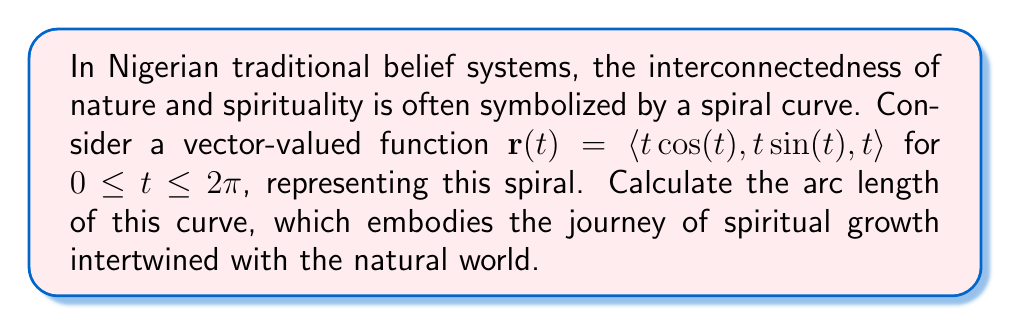Can you solve this math problem? To find the arc length of the curve, we'll follow these steps:

1) The arc length formula for a vector-valued function is:

   $$L = \int_a^b \|\mathbf{r}'(t)\| dt$$

2) First, we need to find $\mathbf{r}'(t)$:
   
   $$\mathbf{r}'(t) = \langle \cos(t) - t\sin(t), \sin(t) + t\cos(t), 1 \rangle$$

3) Now, we calculate $\|\mathbf{r}'(t)\|$:

   $$\begin{align}
   \|\mathbf{r}'(t)\| &= \sqrt{(\cos(t) - t\sin(t))^2 + (\sin(t) + t\cos(t))^2 + 1^2} \\
   &= \sqrt{\cos^2(t) - 2t\cos(t)\sin(t) + t^2\sin^2(t) + \sin^2(t) + 2t\sin(t)\cos(t) + t^2\cos^2(t) + 1} \\
   &= \sqrt{\cos^2(t) + \sin^2(t) + t^2(\sin^2(t) + \cos^2(t)) + 1} \\
   &= \sqrt{1 + t^2 + 1} \\
   &= \sqrt{t^2 + 2}
   \end{align}$$

4) Now we can set up our integral:

   $$L = \int_0^{2\pi} \sqrt{t^2 + 2} dt$$

5) This integral doesn't have an elementary antiderivative. We can solve it using the hyperbolic sine substitution:

   Let $t = \sqrt{2}\sinh(u)$, then $dt = \sqrt{2}\cosh(u)du$

   $$\begin{align}
   L &= \int_0^{\sinh^{-1}(\pi/\sqrt{2})} \sqrt{2\sinh^2(u) + 2} \sqrt{2}\cosh(u)du \\
   &= 2\int_0^{\sinh^{-1}(\pi/\sqrt{2})} \sqrt{\sinh^2(u) + 1} \cosh(u)du \\
   &= 2\int_0^{\sinh^{-1}(\pi/\sqrt{2})} \cosh^2(u)du \\
   &= \left[u + \frac{1}{2}\sinh(2u)\right]_0^{\sinh^{-1}(\pi/\sqrt{2})}
   \end{align}$$

6) Evaluating this expression:

   $$L = \sinh^{-1}(\pi/\sqrt{2}) + \frac{1}{2}\sinh(2\sinh^{-1}(\pi/\sqrt{2}))$$

This represents the spiritual journey's length, intertwining natural cycles (represented by $\pi$) with personal growth (represented by the increasing radius of the spiral).
Answer: The arc length of the curve is $\sinh^{-1}(\pi/\sqrt{2}) + \frac{1}{2}\sinh(2\sinh^{-1}(\pi/\sqrt{2}))$ units. 